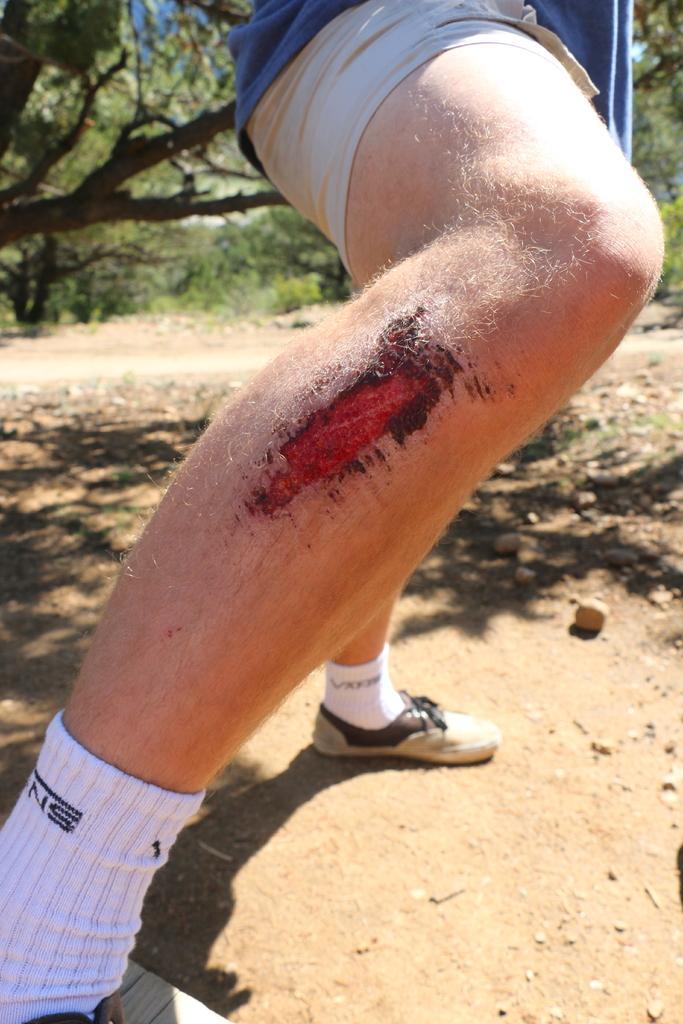Could you give a brief overview of what you see in this image? In the picture we can see a person's leg with a heart on it which is red in color and in the background we can see some grass and trees. 